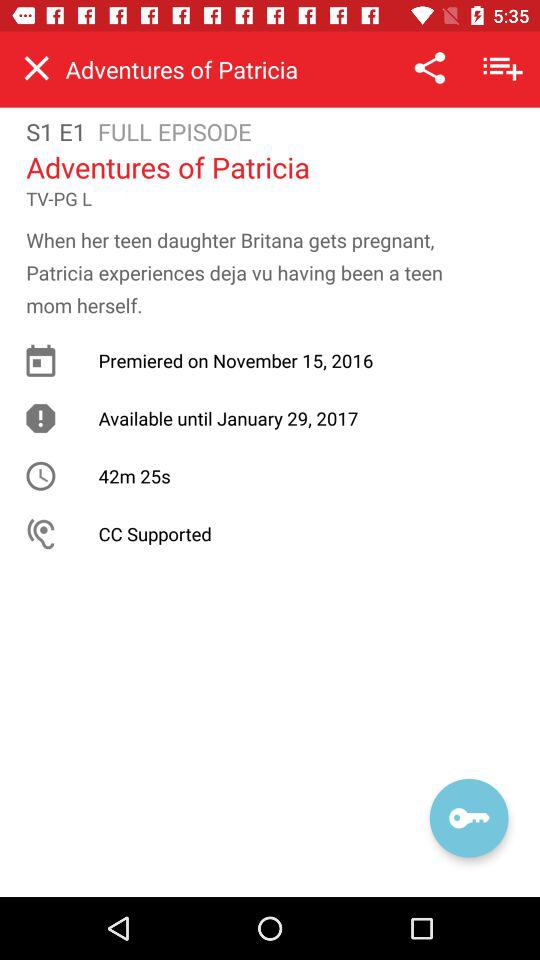Which episode and season are we at right now? You are at episode 1 and season 1. 